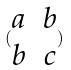Convert formula to latex. <formula><loc_0><loc_0><loc_500><loc_500>( \begin{matrix} a & b \\ b & c \end{matrix} )</formula> 